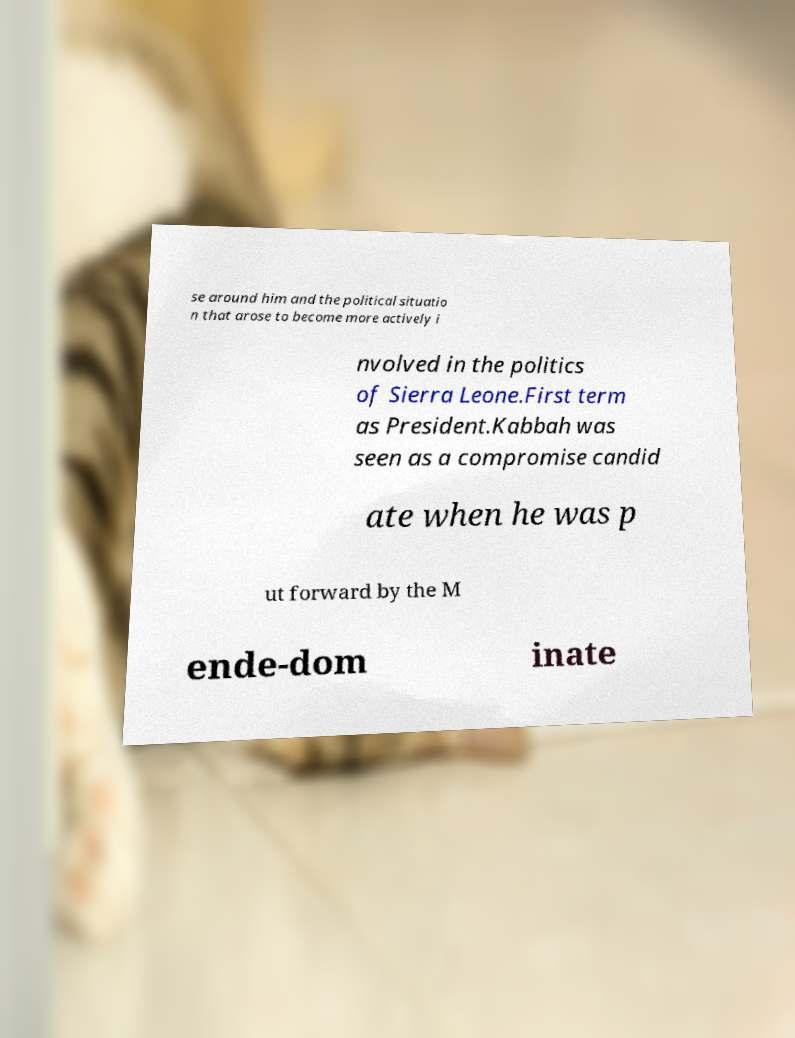Could you assist in decoding the text presented in this image and type it out clearly? se around him and the political situatio n that arose to become more actively i nvolved in the politics of Sierra Leone.First term as President.Kabbah was seen as a compromise candid ate when he was p ut forward by the M ende-dom inate 